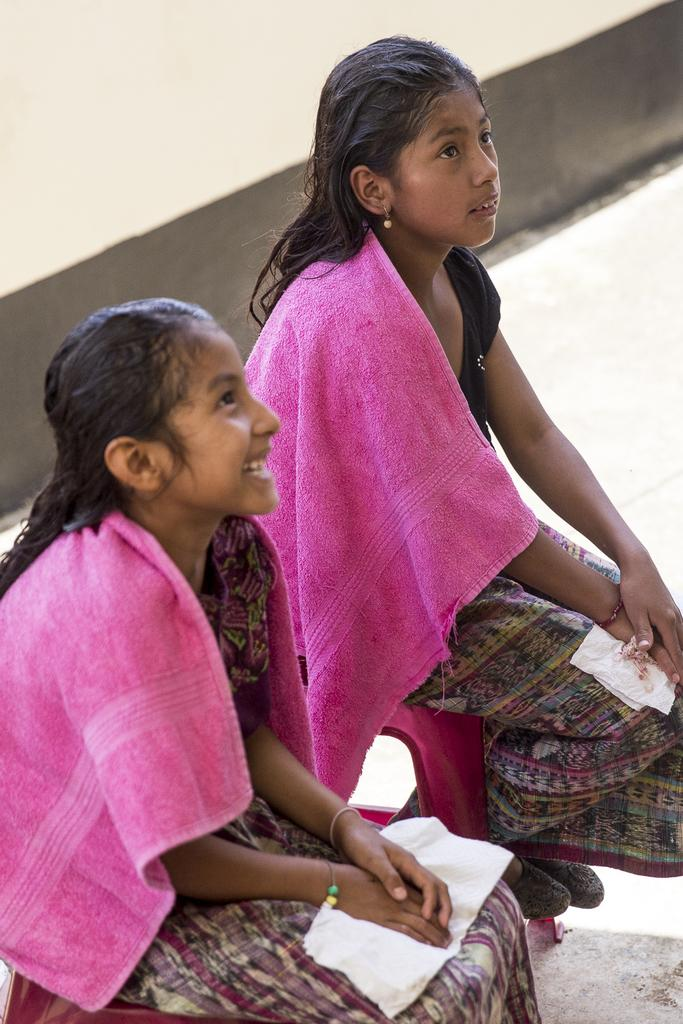How many people are in the image? There are two people in the image. What are the people wearing? The people are wearing colorful dresses. What color are the towels in the image? The towels in the image are pink. What can be seen in the background of the image? The background of the image includes the floor. What type of lamp is being used to light up the party in the image? There is no lamp or party present in the image; it features two people wearing colorful dresses and pink towels. How many fingers does the person on the left have in the image? The number of fingers on the person's hand cannot be determined from the image, as their hands are not visible. 